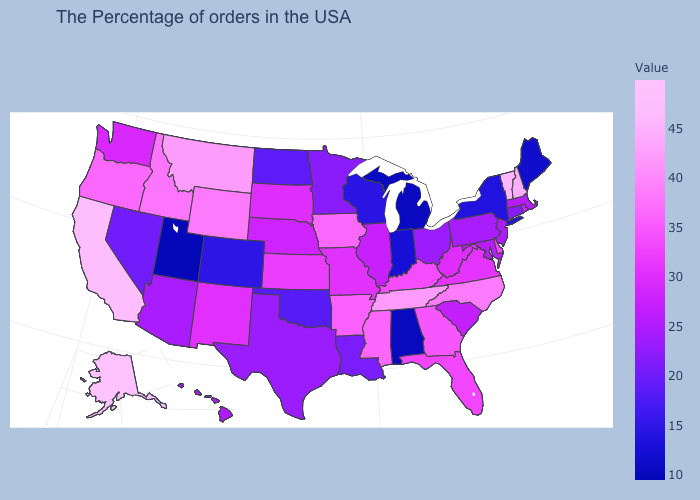Among the states that border Texas , which have the highest value?
Be succinct. Arkansas. Which states have the highest value in the USA?
Keep it brief. Alaska. Which states hav the highest value in the South?
Write a very short answer. Tennessee. Is the legend a continuous bar?
Give a very brief answer. Yes. Does Alaska have the highest value in the USA?
Keep it brief. Yes. Among the states that border Texas , does Arkansas have the highest value?
Be succinct. Yes. 